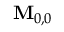<formula> <loc_0><loc_0><loc_500><loc_500>M _ { 0 , 0 }</formula> 